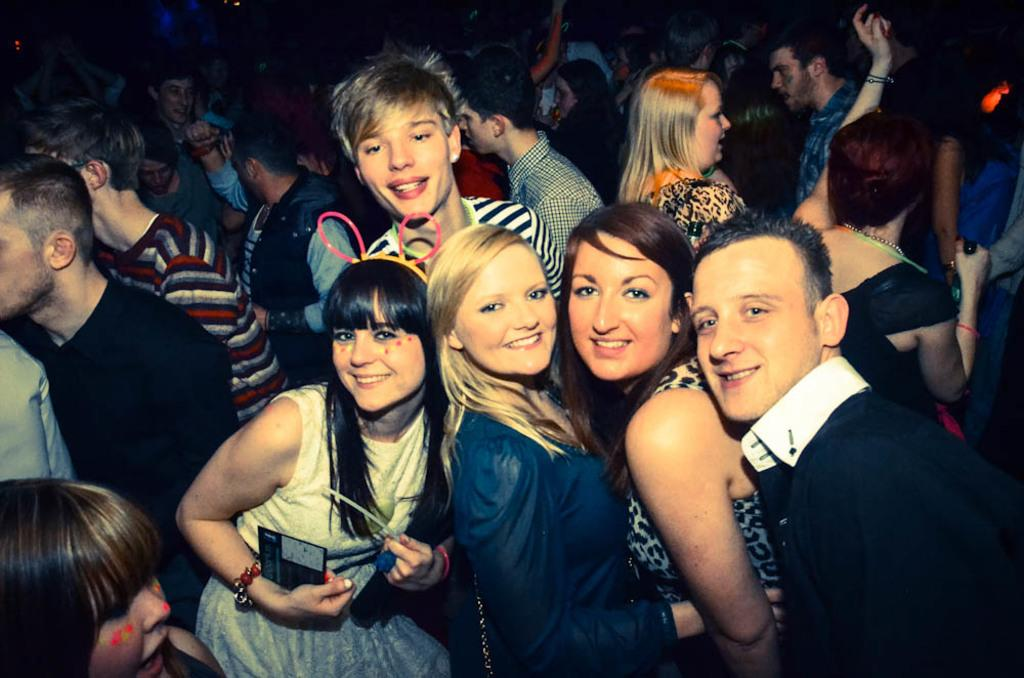How many people are present in the image? There are five persons standing in the image. What is the facial expression of the people in the image? The five persons are smiling. Can you describe the background of the image? There is a group of people in the background of the image. What type of oven is visible in the image? There is no oven present in the image. What kind of apparatus are the people using to play in the image? There is no apparatus or indication of playing in the image; the people are simply standing and smiling. 